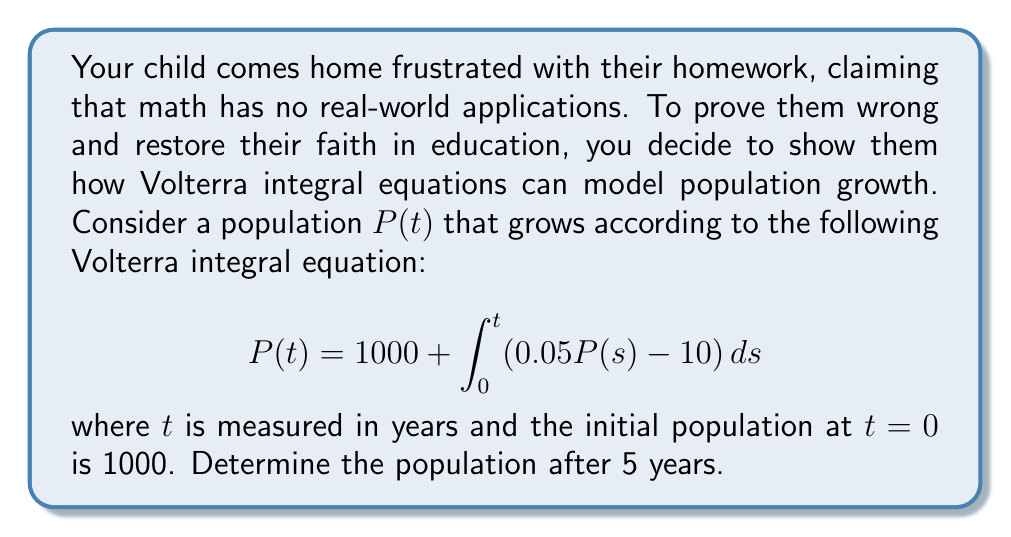Can you answer this question? To solve this Volterra integral equation, we'll follow these steps:

1) First, we differentiate both sides of the equation with respect to $t$:

   $$\frac{d}{dt}P(t) = \frac{d}{dt}\left(1000 + \int_0^t (0.05P(s) - 10) ds\right)$$

2) Using the Fundamental Theorem of Calculus, we get:

   $$\frac{dP}{dt} = 0.05P(t) - 10$$

3) This is now a first-order linear differential equation. We can solve it using the integrating factor method.

4) The integrating factor is $e^{-0.05t}$. Multiplying both sides by this:

   $$e^{-0.05t}\frac{dP}{dt} + 0.05e^{-0.05t}P = -10e^{-0.05t}$$

5) The left side is now the derivative of $e^{-0.05t}P$. So we can integrate both sides:

   $$e^{-0.05t}P = -200e^{-0.05t} + C$$

6) Solving for $P$:

   $$P(t) = -200 + Ce^{0.05t}$$

7) Using the initial condition $P(0) = 1000$, we can find $C$:

   $$1000 = -200 + C \implies C = 1200$$

8) Therefore, the general solution is:

   $$P(t) = -200 + 1200e^{0.05t}$$

9) To find the population after 5 years, we substitute $t=5$:

   $$P(5) = -200 + 1200e^{0.05(5)} = -200 + 1200e^{0.25} \approx 1339.43$$
Answer: 1339 (rounded to nearest whole number) 